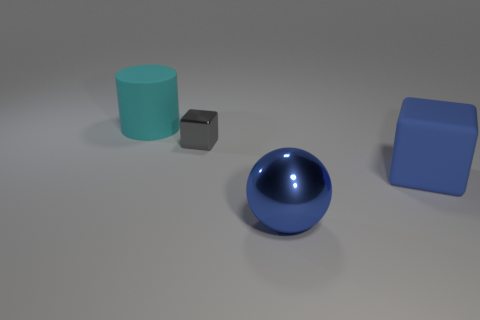Are there any reflective surfaces visible in the image? Yes, the blue sphere has a reflective surface that captures some of the light and surrounding environment, giving it a shiny appearance. The other objects exhibit more matte surfaces and do not reflect their surroundings to the same degree. 